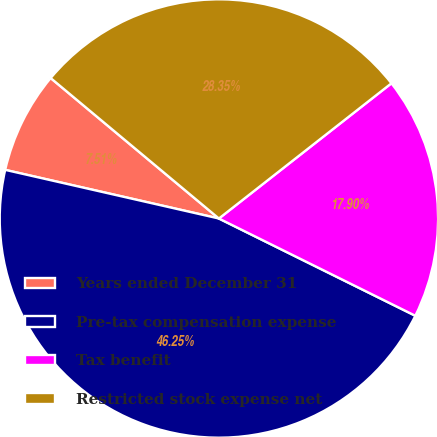Convert chart. <chart><loc_0><loc_0><loc_500><loc_500><pie_chart><fcel>Years ended December 31<fcel>Pre-tax compensation expense<fcel>Tax benefit<fcel>Restricted stock expense net<nl><fcel>7.51%<fcel>46.25%<fcel>17.9%<fcel>28.35%<nl></chart> 